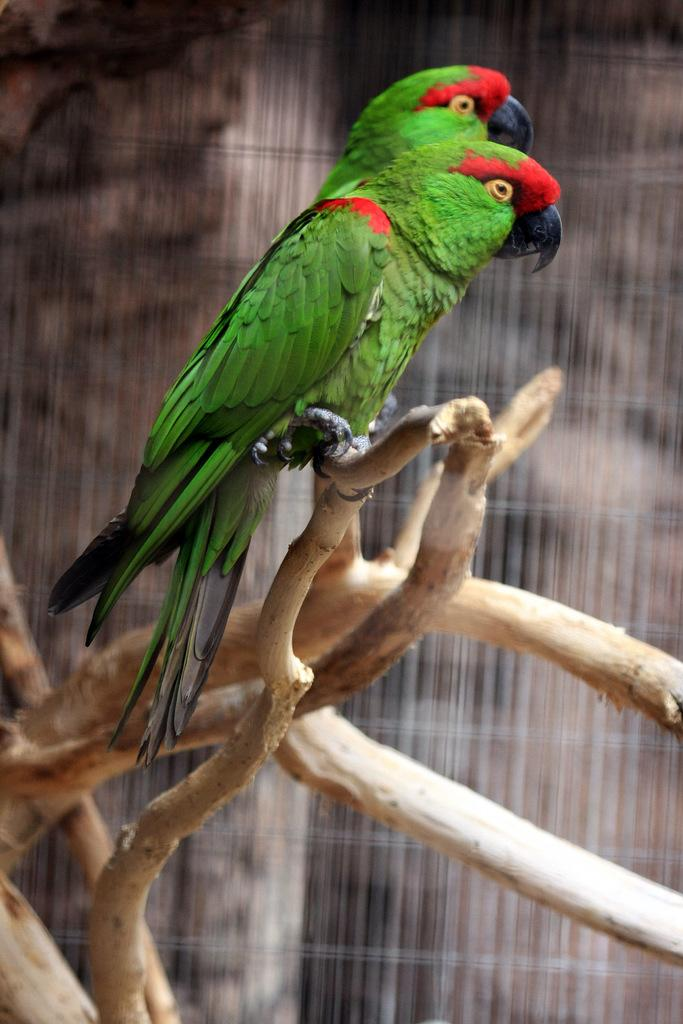What type of animals can be seen in the image? There are birds in the image. What are the birds perched on? The birds are on wooden objects. What can be seen behind the birds in the image? There is a background visible in the image. What type of drink is being served by the police officer in the image? There is no police officer or drink present in the image; it features birds on wooden objects with a background visible. 